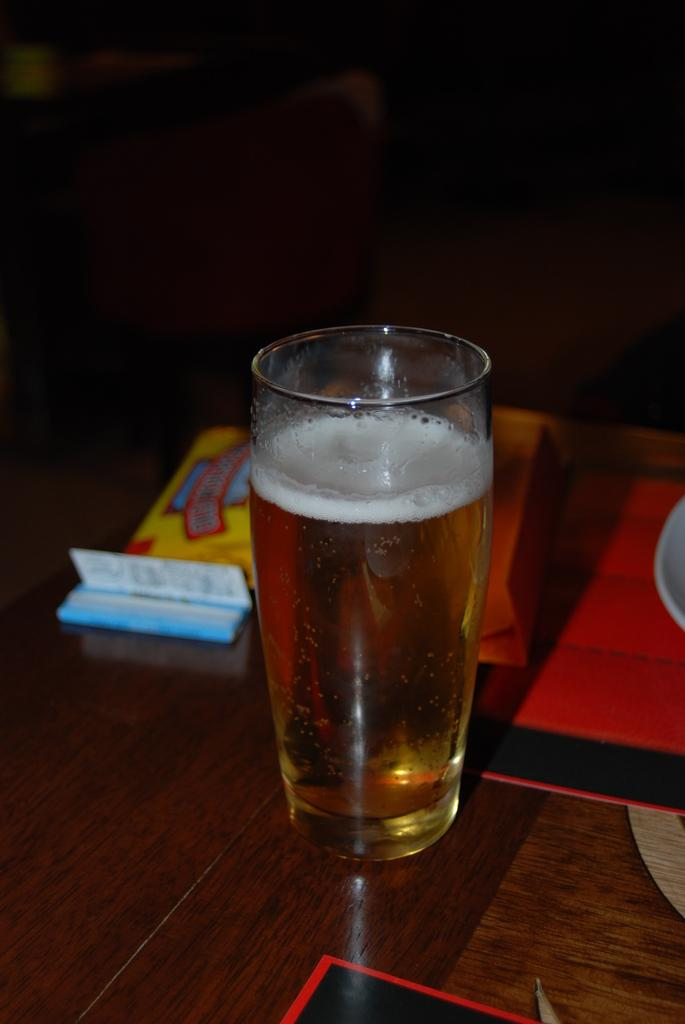What is in the glass that is visible on the table? There is a drink in a glass on the table. What else is on the table besides the glass? There is a plate on the table. Are there any other objects on the table? Yes, there are objects on the table. Is there an earthquake happening in the image? There is no indication of an earthquake in the image. What type of stream is visible in the image? There is no stream present in the image. 